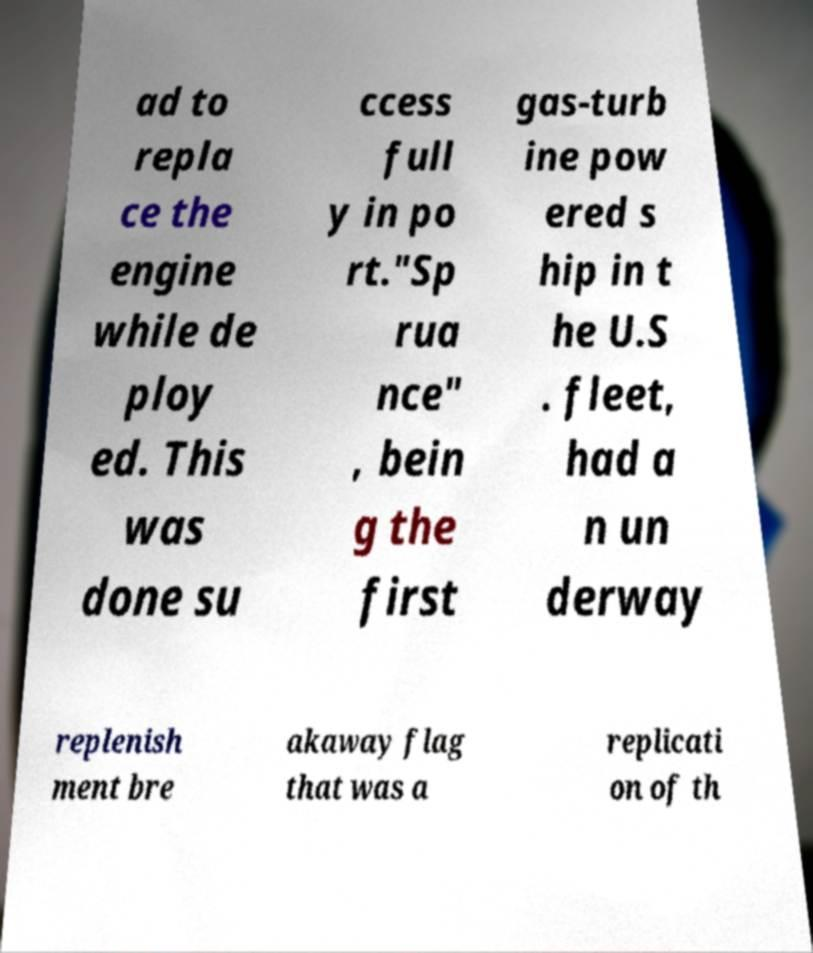Can you accurately transcribe the text from the provided image for me? ad to repla ce the engine while de ploy ed. This was done su ccess full y in po rt."Sp rua nce" , bein g the first gas-turb ine pow ered s hip in t he U.S . fleet, had a n un derway replenish ment bre akaway flag that was a replicati on of th 